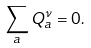<formula> <loc_0><loc_0><loc_500><loc_500>\sum _ { a } Q ^ { \nu } _ { a } = 0 .</formula> 